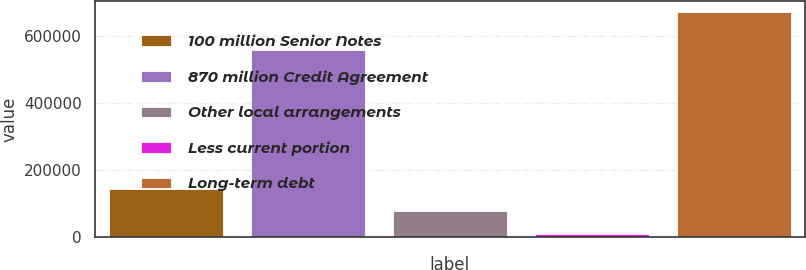<chart> <loc_0><loc_0><loc_500><loc_500><bar_chart><fcel>100 million Senior Notes<fcel>870 million Credit Agreement<fcel>Other local arrangements<fcel>Less current portion<fcel>Long-term debt<nl><fcel>142782<fcel>556481<fcel>76841.9<fcel>10902<fcel>670301<nl></chart> 